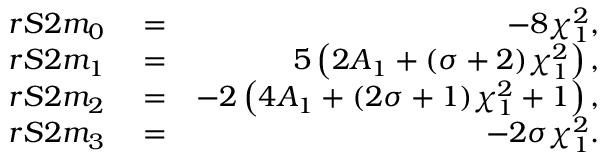<formula> <loc_0><loc_0><loc_500><loc_500>\begin{array} { r l r } { r S 2 m _ { 0 } } & = } & { - 8 \chi _ { 1 } ^ { 2 } , } \\ { r S 2 m _ { 1 } } & = } & { 5 \left ( 2 A _ { 1 } + ( \sigma + 2 ) \chi _ { 1 } ^ { 2 } \right ) , } \\ { r S 2 m _ { 2 } } & = } & { - 2 \left ( 4 A _ { 1 } + ( 2 \sigma + 1 ) \chi _ { 1 } ^ { 2 } + 1 \right ) , } \\ { r S 2 m _ { 3 } } & = } & { - 2 \sigma \chi _ { 1 } ^ { 2 } . } \end{array}</formula> 